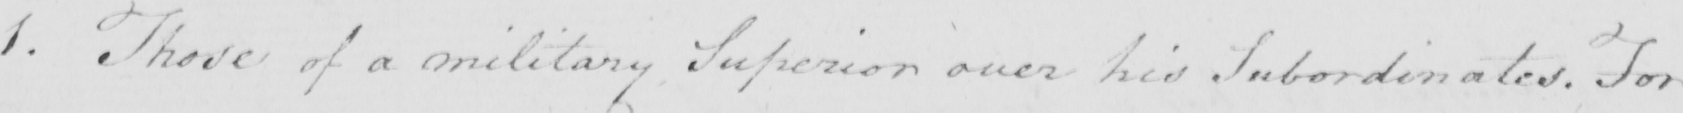Please provide the text content of this handwritten line. 1 . Those of a military Superior over his Subordinates . For 